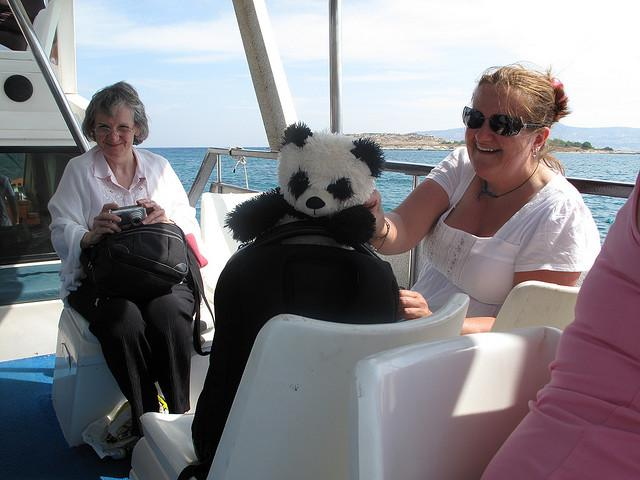What digital device is being used to capture memories? Please explain your reasoning. camera. A group of women are sitting on a boat. one has a device in her hand that is small and has a lens for capturing pictures. 